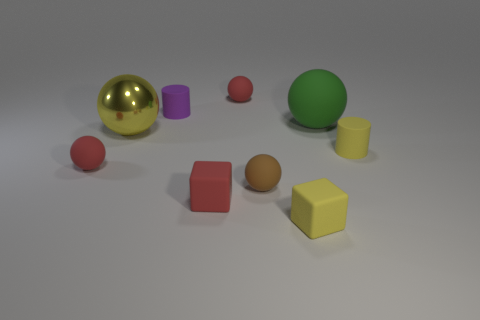Are there the same number of yellow metal balls that are right of the red cube and big yellow things in front of the large yellow ball?
Your answer should be compact. Yes. What number of other objects are the same color as the large shiny ball?
Keep it short and to the point. 2. Is the number of tiny brown rubber objects that are behind the small brown thing the same as the number of green metallic cubes?
Keep it short and to the point. Yes. Does the shiny sphere have the same size as the green object?
Ensure brevity in your answer.  Yes. There is a small red object that is both in front of the large shiny sphere and behind the brown ball; what material is it made of?
Your response must be concise. Rubber. How many brown things are the same shape as the green object?
Give a very brief answer. 1. What material is the red thing that is behind the big green rubber thing?
Offer a very short reply. Rubber. Are there fewer brown spheres on the right side of the brown thing than yellow metallic things?
Provide a succinct answer. Yes. Is the shape of the brown object the same as the big shiny object?
Provide a short and direct response. Yes. Are there any gray metal spheres?
Your answer should be compact. No. 